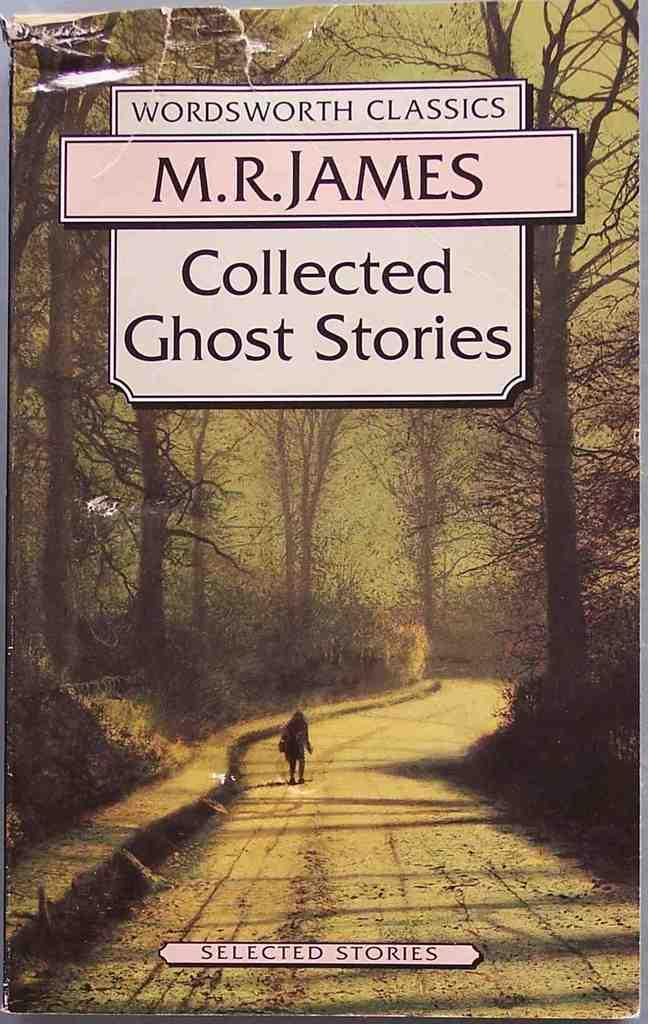<image>
Offer a succinct explanation of the picture presented. The book cover for the book Collected Ghost Stories by M.R. James. 